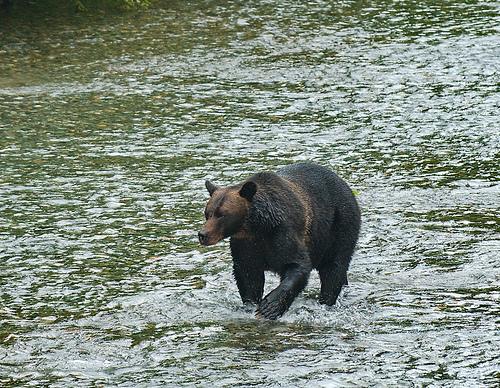What color is the water?
Concise answer only. Green. Is this animal looking for food?
Keep it brief. Yes. What animal is this?
Give a very brief answer. Bear. 